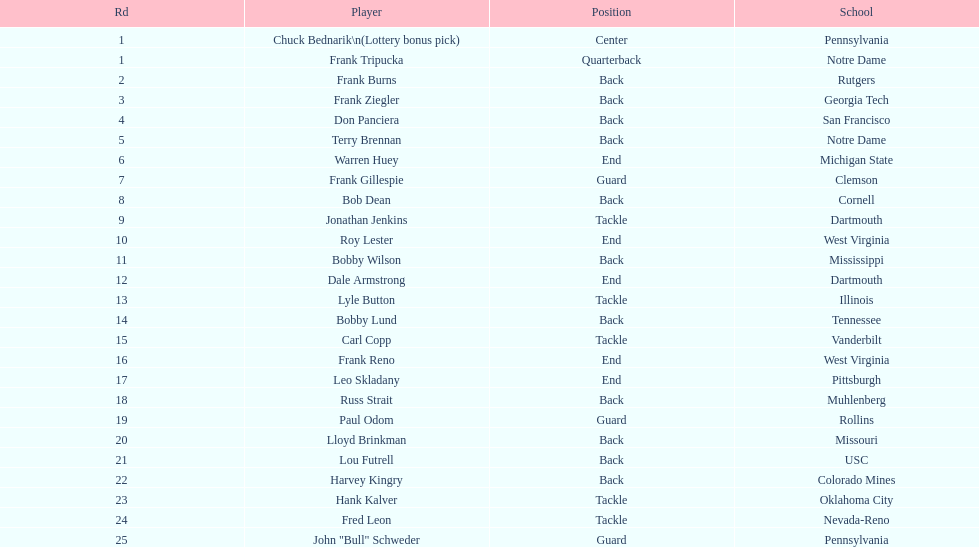Greatest rd figure? 25. Help me parse the entirety of this table. {'header': ['Rd', 'Player', 'Position', 'School'], 'rows': [['1', 'Chuck Bednarik\\n(Lottery bonus pick)', 'Center', 'Pennsylvania'], ['1', 'Frank Tripucka', 'Quarterback', 'Notre Dame'], ['2', 'Frank Burns', 'Back', 'Rutgers'], ['3', 'Frank Ziegler', 'Back', 'Georgia Tech'], ['4', 'Don Panciera', 'Back', 'San Francisco'], ['5', 'Terry Brennan', 'Back', 'Notre Dame'], ['6', 'Warren Huey', 'End', 'Michigan State'], ['7', 'Frank Gillespie', 'Guard', 'Clemson'], ['8', 'Bob Dean', 'Back', 'Cornell'], ['9', 'Jonathan Jenkins', 'Tackle', 'Dartmouth'], ['10', 'Roy Lester', 'End', 'West Virginia'], ['11', 'Bobby Wilson', 'Back', 'Mississippi'], ['12', 'Dale Armstrong', 'End', 'Dartmouth'], ['13', 'Lyle Button', 'Tackle', 'Illinois'], ['14', 'Bobby Lund', 'Back', 'Tennessee'], ['15', 'Carl Copp', 'Tackle', 'Vanderbilt'], ['16', 'Frank Reno', 'End', 'West Virginia'], ['17', 'Leo Skladany', 'End', 'Pittsburgh'], ['18', 'Russ Strait', 'Back', 'Muhlenberg'], ['19', 'Paul Odom', 'Guard', 'Rollins'], ['20', 'Lloyd Brinkman', 'Back', 'Missouri'], ['21', 'Lou Futrell', 'Back', 'USC'], ['22', 'Harvey Kingry', 'Back', 'Colorado Mines'], ['23', 'Hank Kalver', 'Tackle', 'Oklahoma City'], ['24', 'Fred Leon', 'Tackle', 'Nevada-Reno'], ['25', 'John "Bull" Schweder', 'Guard', 'Pennsylvania']]} 